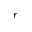<formula> <loc_0><loc_0><loc_500><loc_500>r</formula> 